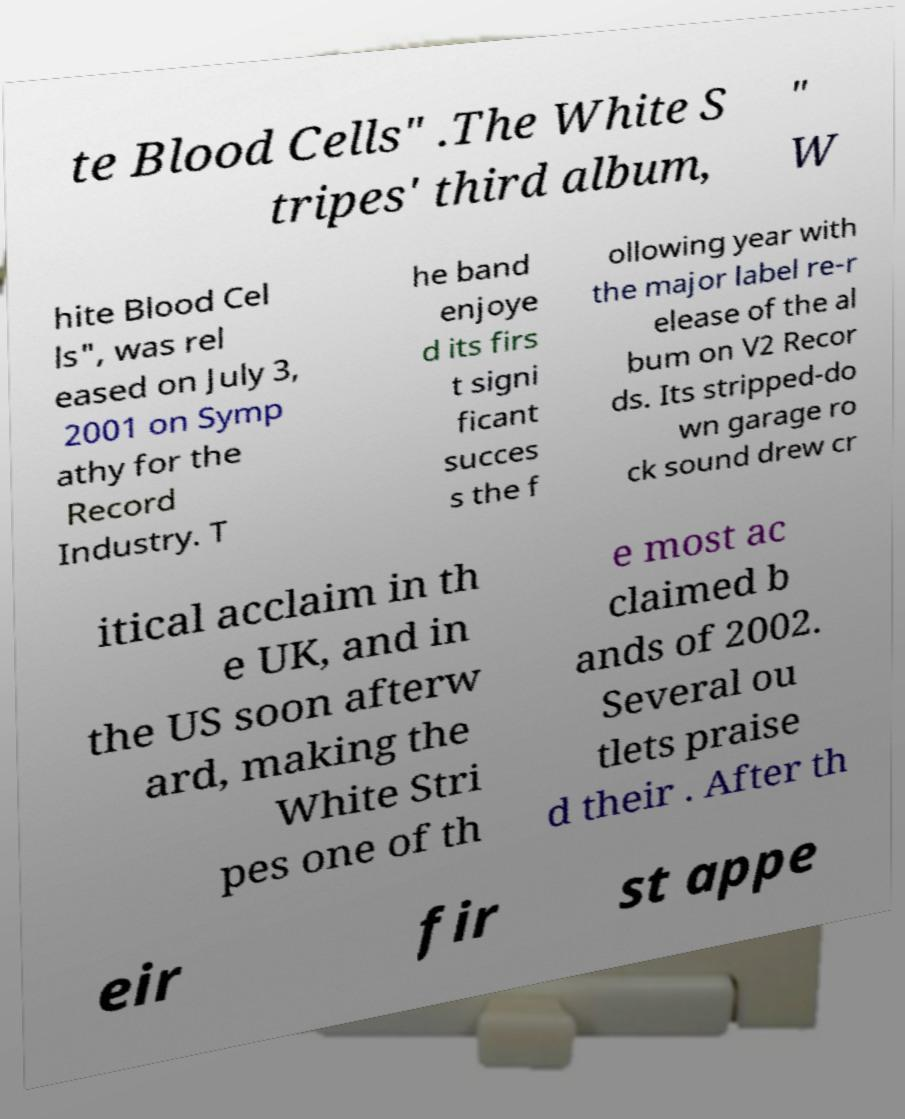There's text embedded in this image that I need extracted. Can you transcribe it verbatim? te Blood Cells" .The White S tripes' third album, " W hite Blood Cel ls", was rel eased on July 3, 2001 on Symp athy for the Record Industry. T he band enjoye d its firs t signi ficant succes s the f ollowing year with the major label re-r elease of the al bum on V2 Recor ds. Its stripped-do wn garage ro ck sound drew cr itical acclaim in th e UK, and in the US soon afterw ard, making the White Stri pes one of th e most ac claimed b ands of 2002. Several ou tlets praise d their . After th eir fir st appe 